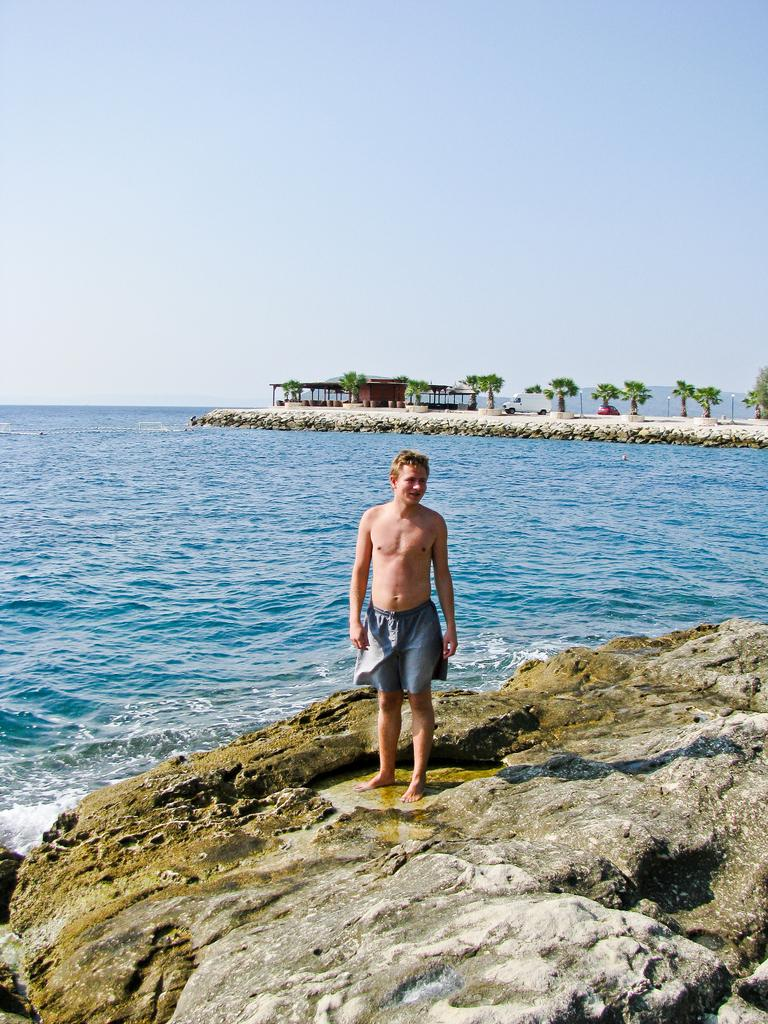What is the person in the image standing on? The person is standing on a rock. What can be seen near the rock in the image? There is an ocean near the rock. What type of vegetation is visible in the image? There are trees visible in the image. What structure can be seen in the image? There is a shelter in the image. What thought is the person holding in their hand in the image? There is no indication of a thought being held in the person's hand in the image. Is there a parcel visible in the image? There is no parcel present in the image. 